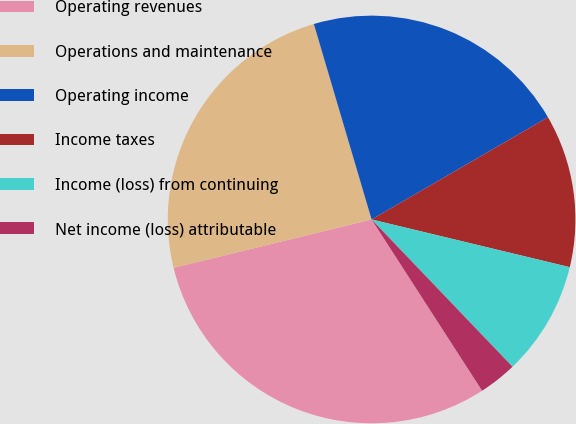<chart> <loc_0><loc_0><loc_500><loc_500><pie_chart><fcel>Operating revenues<fcel>Operations and maintenance<fcel>Operating income<fcel>Income taxes<fcel>Income (loss) from continuing<fcel>Net income (loss) attributable<nl><fcel>30.3%<fcel>24.24%<fcel>21.21%<fcel>12.12%<fcel>9.09%<fcel>3.03%<nl></chart> 